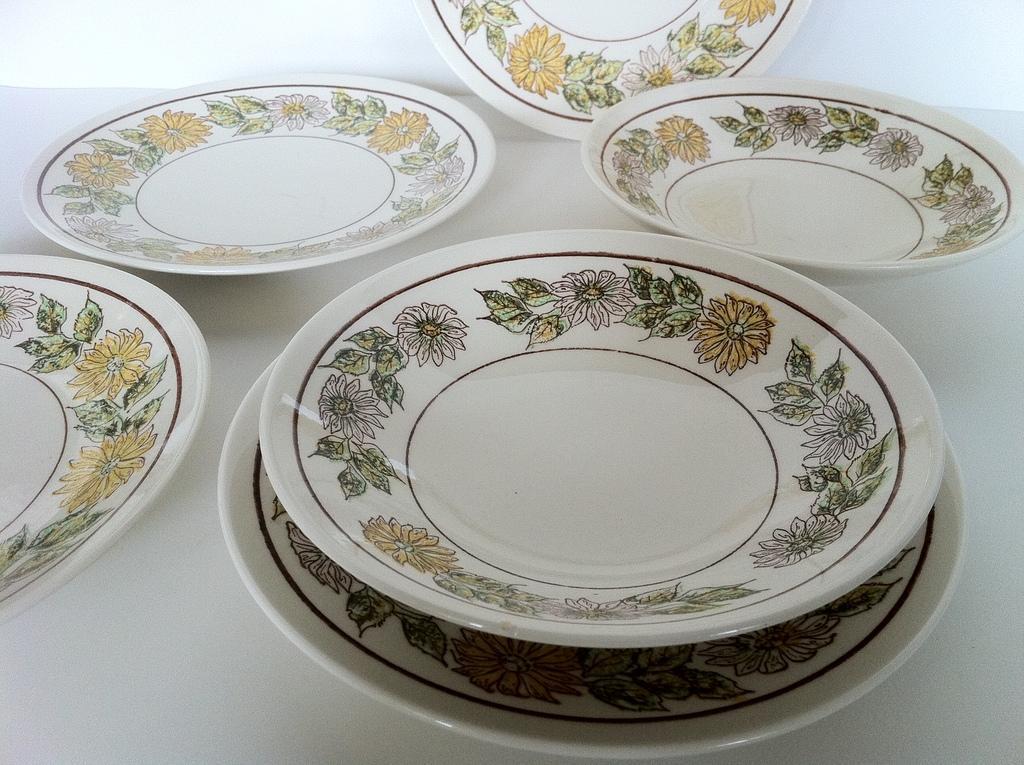In one or two sentences, can you explain what this image depicts? In this image I can see few white colour plates. On these plates I can see design of flowers. 